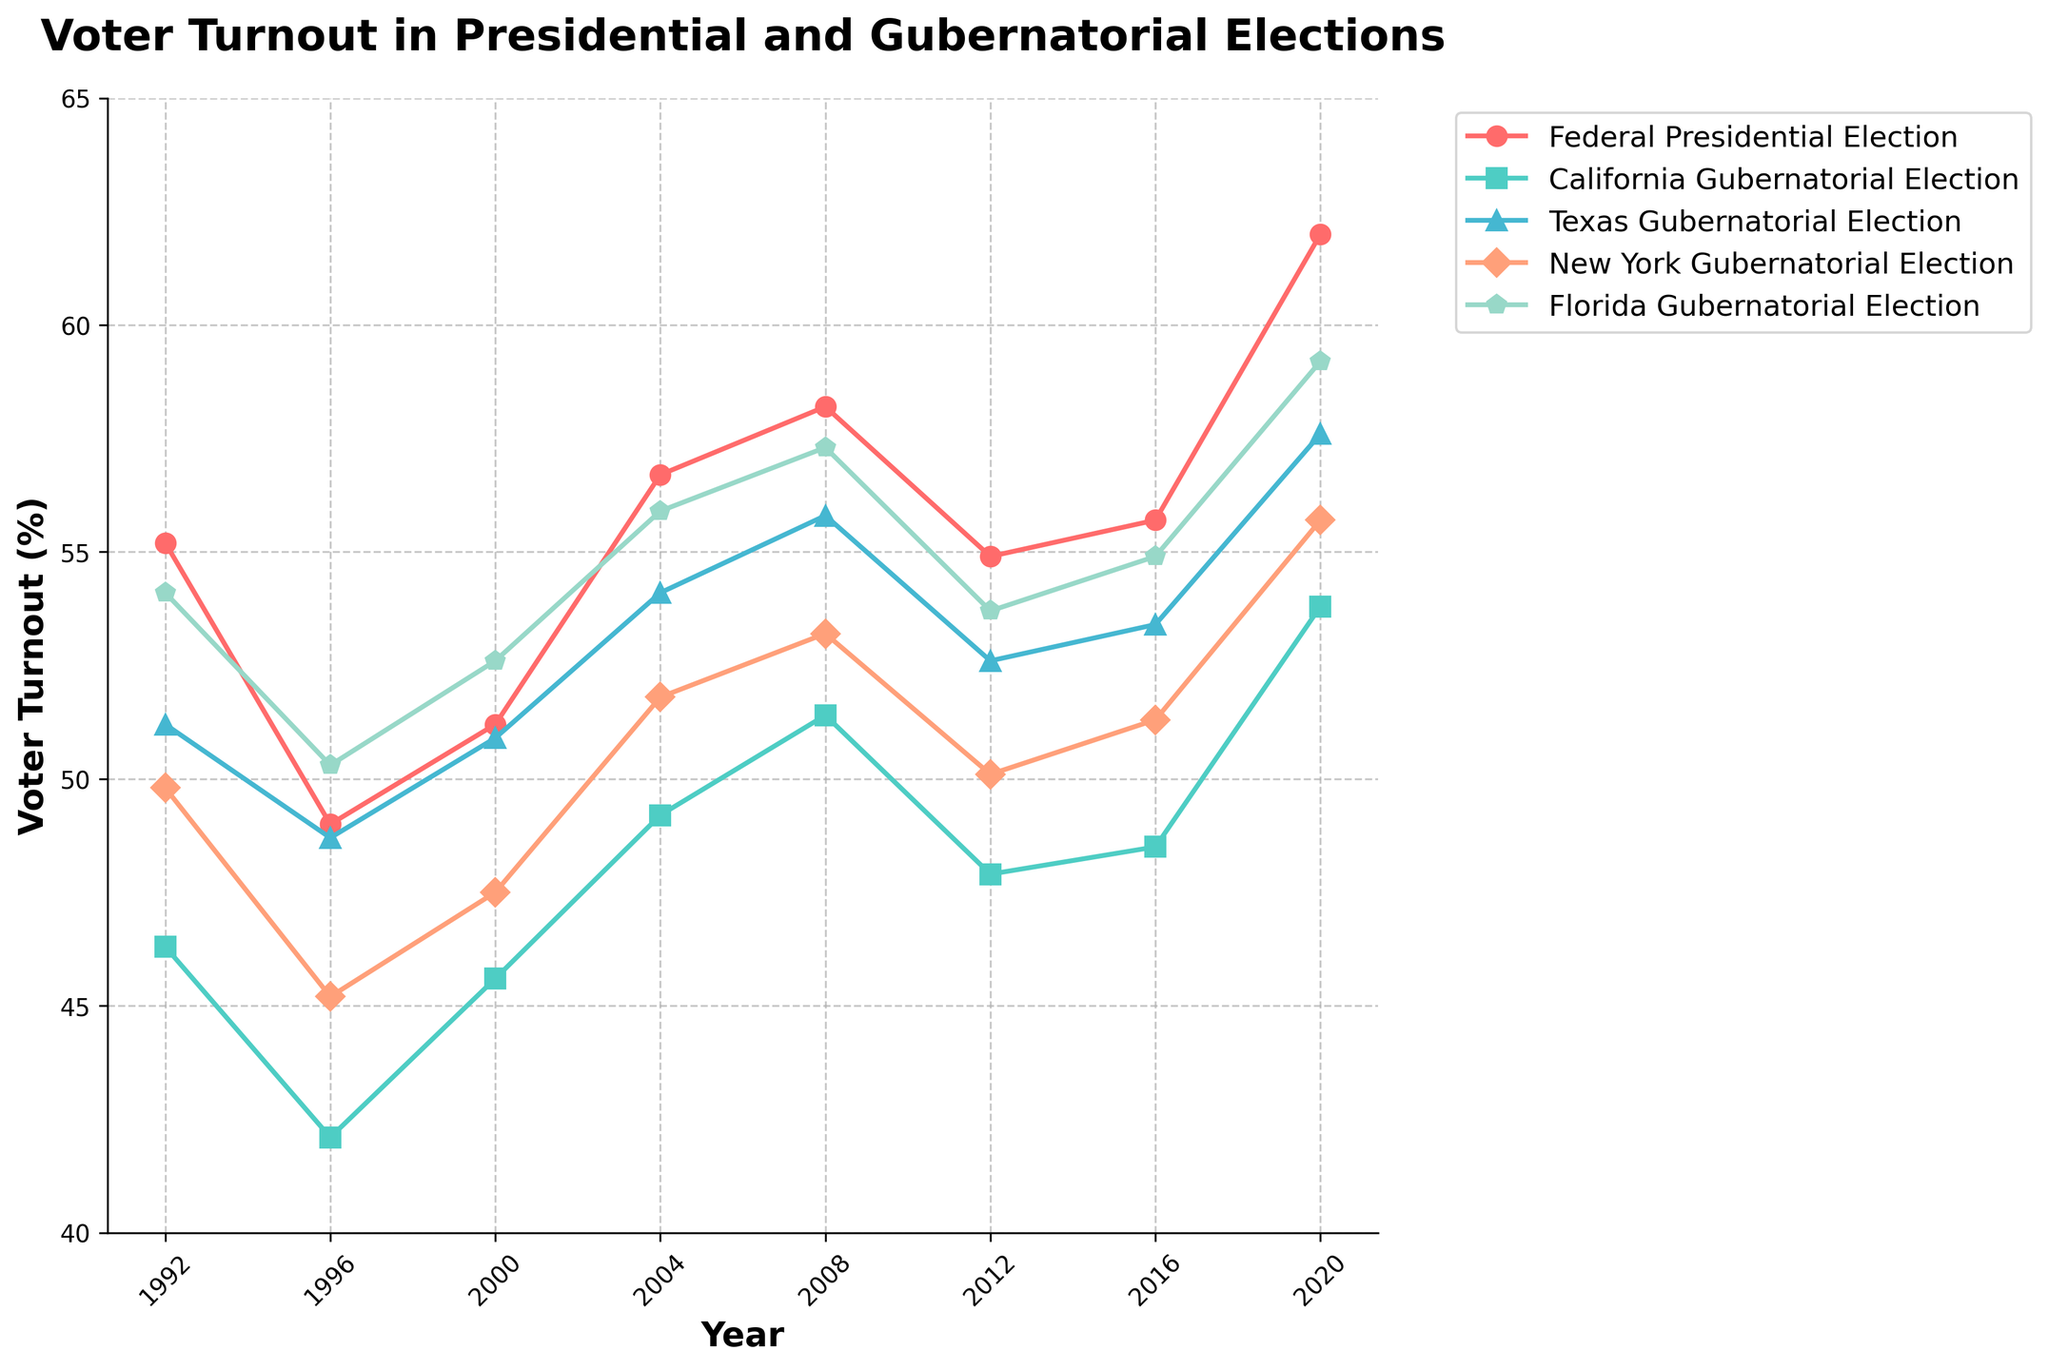what trend can be observed in the federal presidential election voter turnout from 1992 to 2020? The line for the federal presidential election shows a general upward trend with fluctuations, reaching its peak in 2020.
Answer: Overall increase Which election consistently had the lowest voter turnout across the years? By visually inspecting the plot, California Gubernatorial Election has the lowest voter turnout percentages in most years.
Answer: California Gubernatorial Election In which year did Texas have the highest voter turnout for gubernatorial elections? The highest point on the line representing Texas Gubernatorial Election is in 2020.
Answer: 2020 How does the voter turnout for New York gubernatorial elections in 2008 compare with the federal presidential election in the same year? The plot shows that the voter turnout for New York gubernatorial elections is approximately 53.2%, whereas for the federal presidential election it is 58.2%. So, the federal turnout is higher.
Answer: Federal is higher What is the average voter turnout for Florida gubernatorial elections from 1992 to 2020? Sum of Florida's turnouts (54.1 + 50.3 + 52.6 + 55.9 + 57.3 + 53.7 + 54.9 + 59.2) is 388, and the number of years is 8. Average is 388/8.
Answer: 48.75 Which state's gubernatorial election had the closest voter turnout percentage to the federal presidential election in 2004? By comparing the voter turnout percentages in 2004, Texas Gubernatorial (54.1%) is closest to the federal presidential election (56.7%).
Answer: Texas Gubernatorial Between 2000 and 2020, which gubernatorial election showed the highest overall increase in voter turnout percentage? Calculate the difference between 2020 and 2000 for each state: California (53.8-45.6=8.2), Texas (57.6-50.9=6.7), New York (55.7-47.5=8.2), Florida (59.2-52.6=6.6). Both California and New York had the highest increase of 8.2.
Answer: California and New York What is the difference in voter turnout between the federal presidential election and California gubernatorial election in 2020? The voter turnout for the federal presidential election in 2020 is 62.0%, and for California gubernatorial election it is 53.8%. The difference is 62.0 - 53.8.
Answer: 8.2 